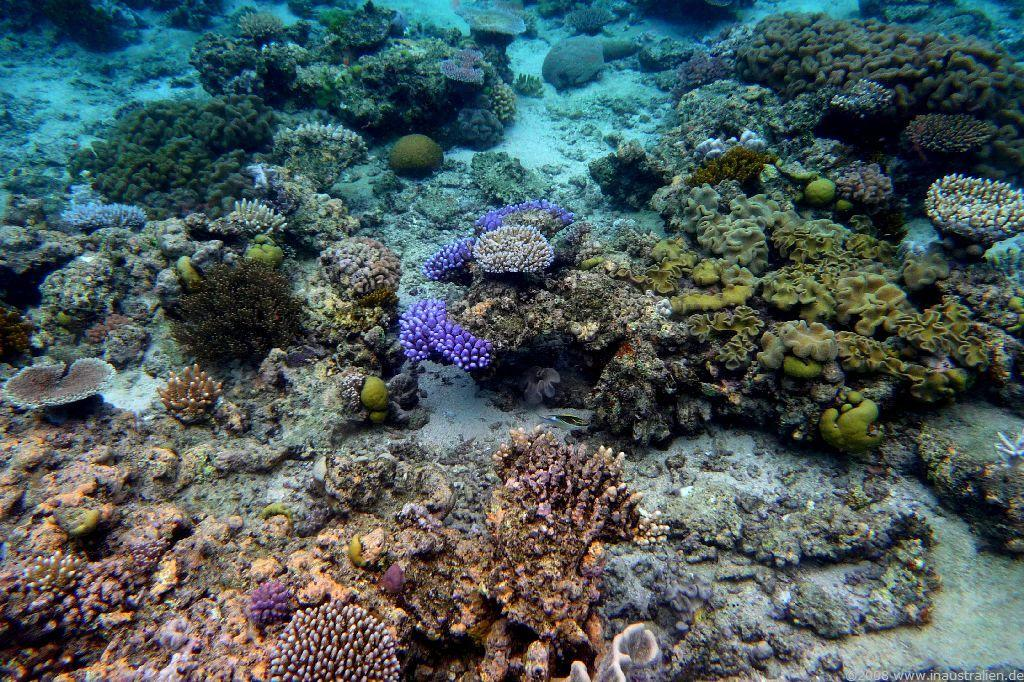What type of environment is shown in the image? The image depicts an underwater environment. What specific features can be seen in this environment? There are corals visible in the image. How does the cast of a play perform in the image? There is no cast of a play present in the image; it depicts an underwater environment with corals. Can you see any icicles in the image? There are no icicles present in the image, as it depicts an underwater environment. 